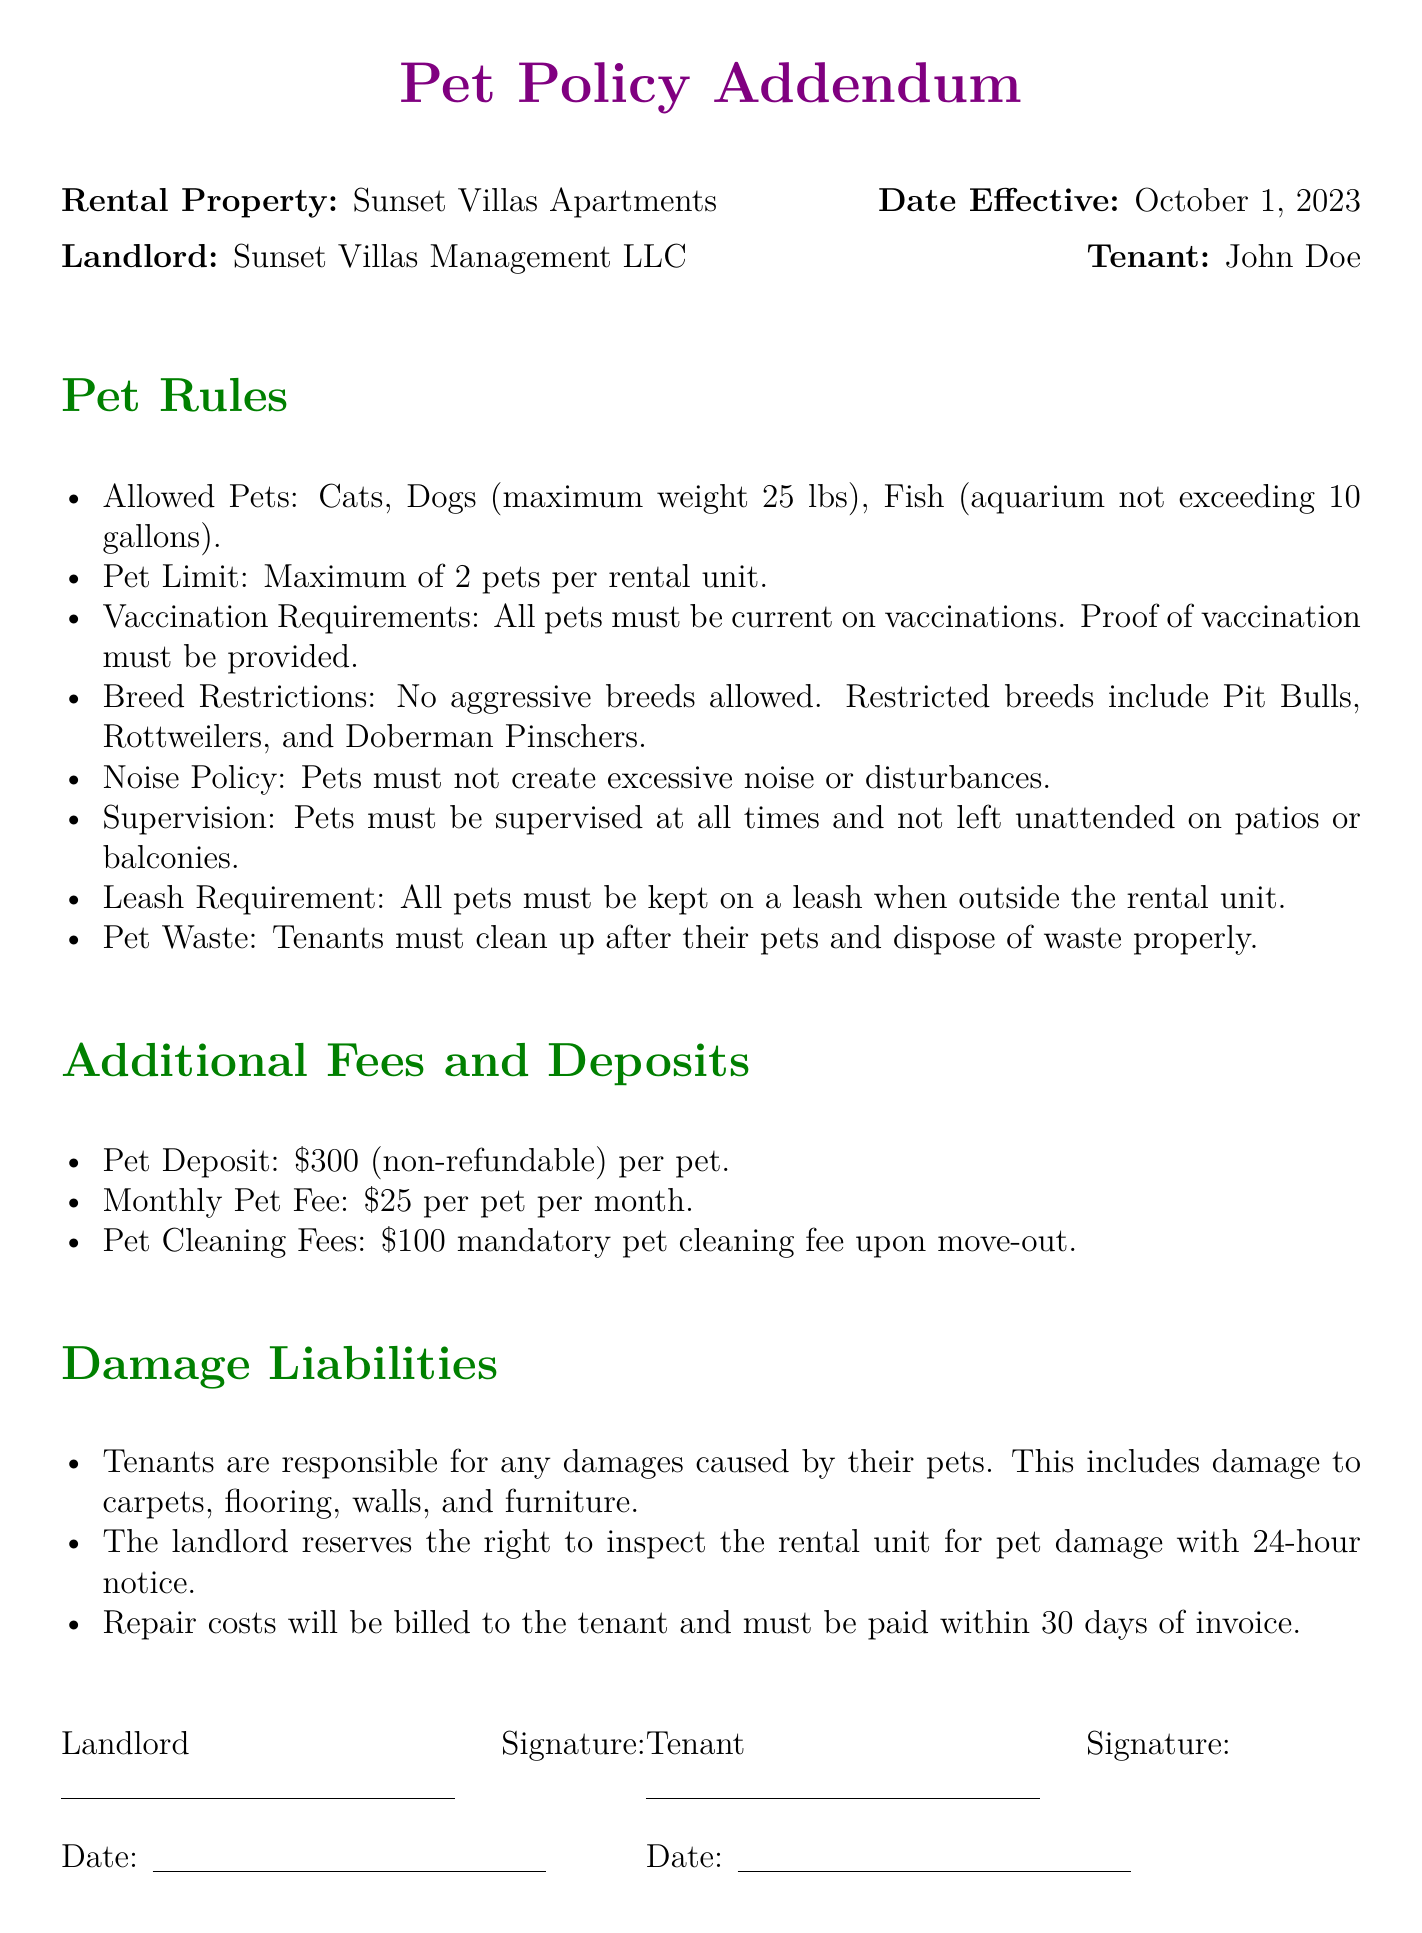What is the maximum weight for dogs allowed? The document specifies that the maximum weight for dogs is 25 lbs.
Answer: 25 lbs How many pets can a tenant have? The pet policy states that the maximum number of pets allowed per rental unit is 2.
Answer: 2 pets What is the pet deposit amount? According to the additional fees section, the non-refundable pet deposit is $300 per pet.
Answer: $300 Which aggressive breeds are not allowed? The document lists specific breeds that are restricted, including Pit Bulls, Rottweilers, and Doberman Pinschers.
Answer: Pit Bulls, Rottweilers, Doberman Pinschers What fee must be paid monthly for each pet? The monthly pet fee is mentioned as $25 per pet in the additional fees section.
Answer: $25 What must tenants do with pet waste? The pet rules state that tenants must clean up after their pets and dispose of waste properly.
Answer: Clean up and dispose of waste What is the mandatory fee upon move-out for cleaning? The document specifies a mandatory pet cleaning fee of $100 upon move-out.
Answer: $100 How long before inspections does the landlord need to notify tenants? The document states that the landlord must provide 24-hour notice before inspecting the rental unit for pet damage.
Answer: 24-hour notice Who is responsible for pet damages? The damage liabilities section states that tenants are responsible for any damages caused by their pets.
Answer: Tenants 